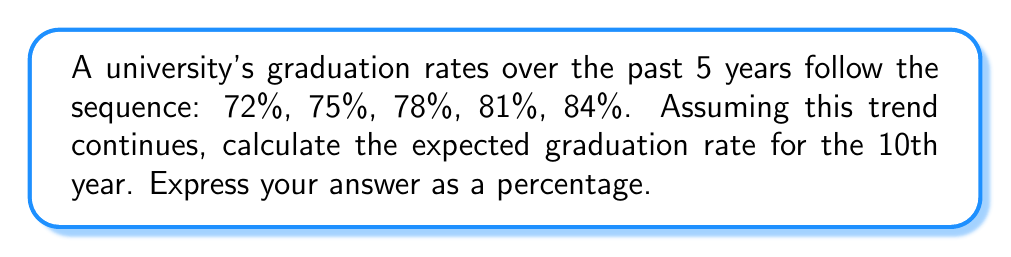Show me your answer to this math problem. Let's approach this step-by-step:

1) First, we need to identify the pattern in the sequence:
   72%, 75%, 78%, 81%, 84%

2) We can see that the rate increases by 3% each year. This is an arithmetic sequence.

3) In an arithmetic sequence, the nth term is given by the formula:
   $a_n = a_1 + (n-1)d$
   Where $a_1$ is the first term, $n$ is the position of the term we're looking for, and $d$ is the common difference.

4) In this case:
   $a_1 = 72$ (first term)
   $d = 3$ (common difference)
   $n = 10$ (we want the 10th year)

5) Plugging these into our formula:
   $a_{10} = 72 + (10-1)3$

6) Simplify:
   $a_{10} = 72 + (9)3 = 72 + 27 = 99$

7) Therefore, the graduation rate for the 10th year would be 99%.
Answer: 99% 